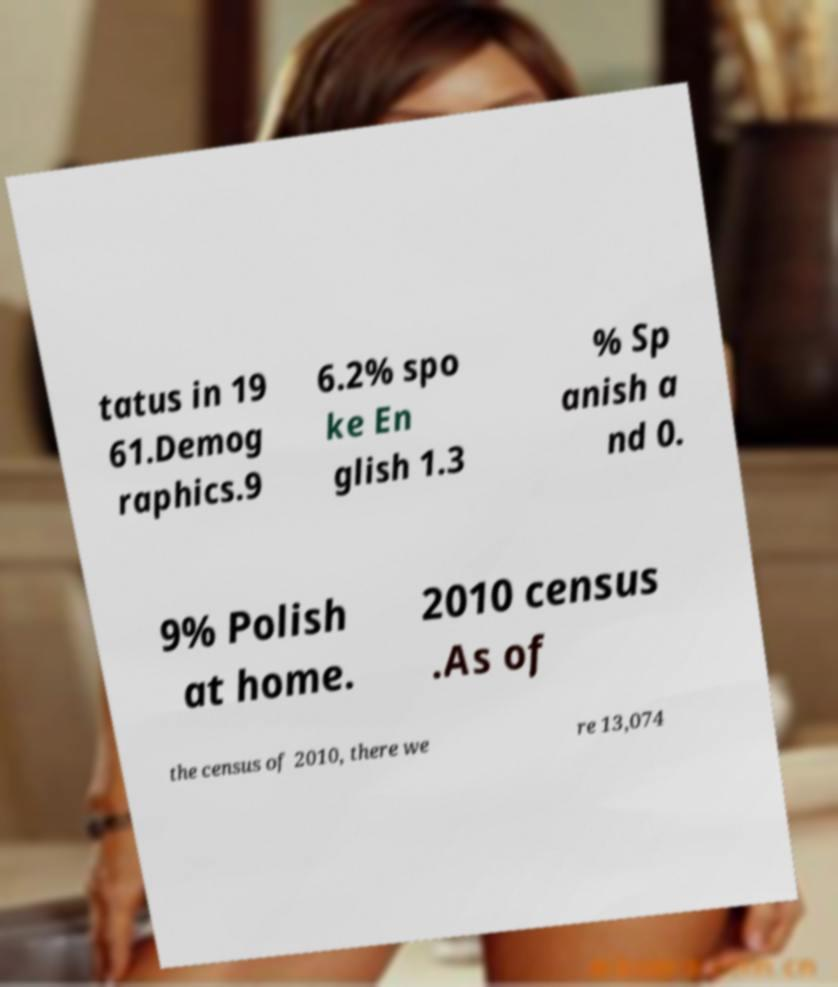Can you accurately transcribe the text from the provided image for me? tatus in 19 61.Demog raphics.9 6.2% spo ke En glish 1.3 % Sp anish a nd 0. 9% Polish at home. 2010 census .As of the census of 2010, there we re 13,074 